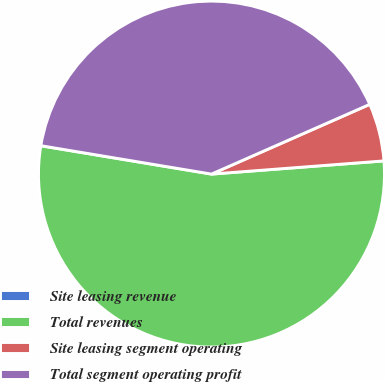Convert chart to OTSL. <chart><loc_0><loc_0><loc_500><loc_500><pie_chart><fcel>Site leasing revenue<fcel>Total revenues<fcel>Site leasing segment operating<fcel>Total segment operating profit<nl><fcel>0.01%<fcel>53.83%<fcel>5.39%<fcel>40.77%<nl></chart> 